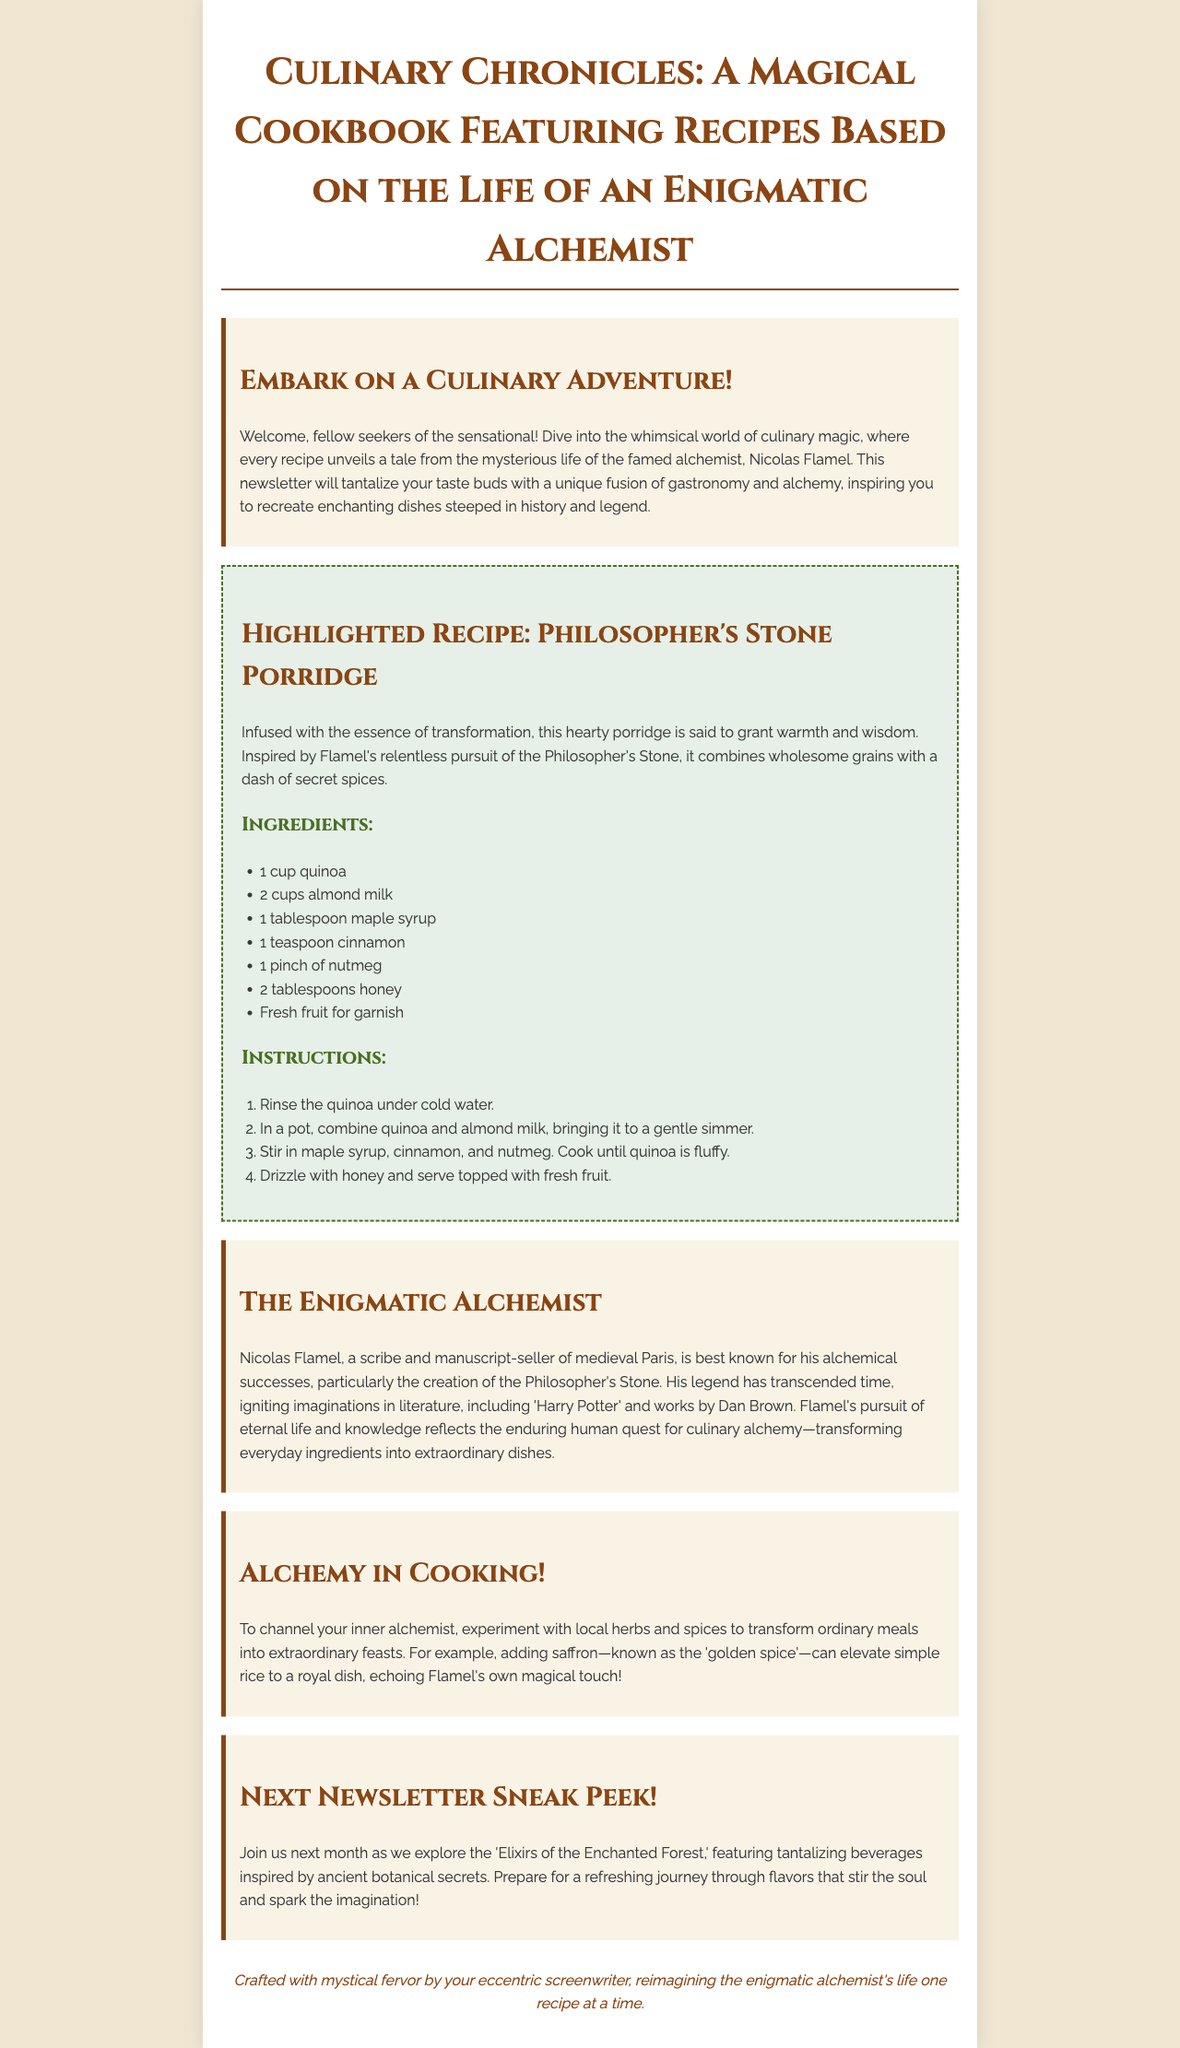What is the title of the cookbook? The title is found in the main heading of the document.
Answer: Culinary Chronicles: A Magical Cookbook Featuring Recipes Based on the Life of an Enigmatic Alchemist Who is the famous alchemist mentioned? The alchemist is introduced in the thematic context of the newsletter.
Answer: Nicolas Flamel What is the highlighted recipe? The highlighted recipe details are prominently featured in the document.
Answer: Philosopher's Stone Porridge How many cups of quinoa are needed? The recipe section lists ingredients and their quantities.
Answer: 1 cup What is the main theme of the newsletter? The theme is indicated in the introduction and throughout the document.
Answer: Culinary magic What should you experiment with to channel your inner alchemist? This is stated in the culinary tip section of the newsletter.
Answer: Local herbs and spices What beverage will be discussed in the next newsletter? The next newsletter sneak peek hints at its content.
Answer: Elixirs of the Enchanted Forest What color is the background of the document? The background color is described in the body styling of the document.
Answer: #f0e6d2 